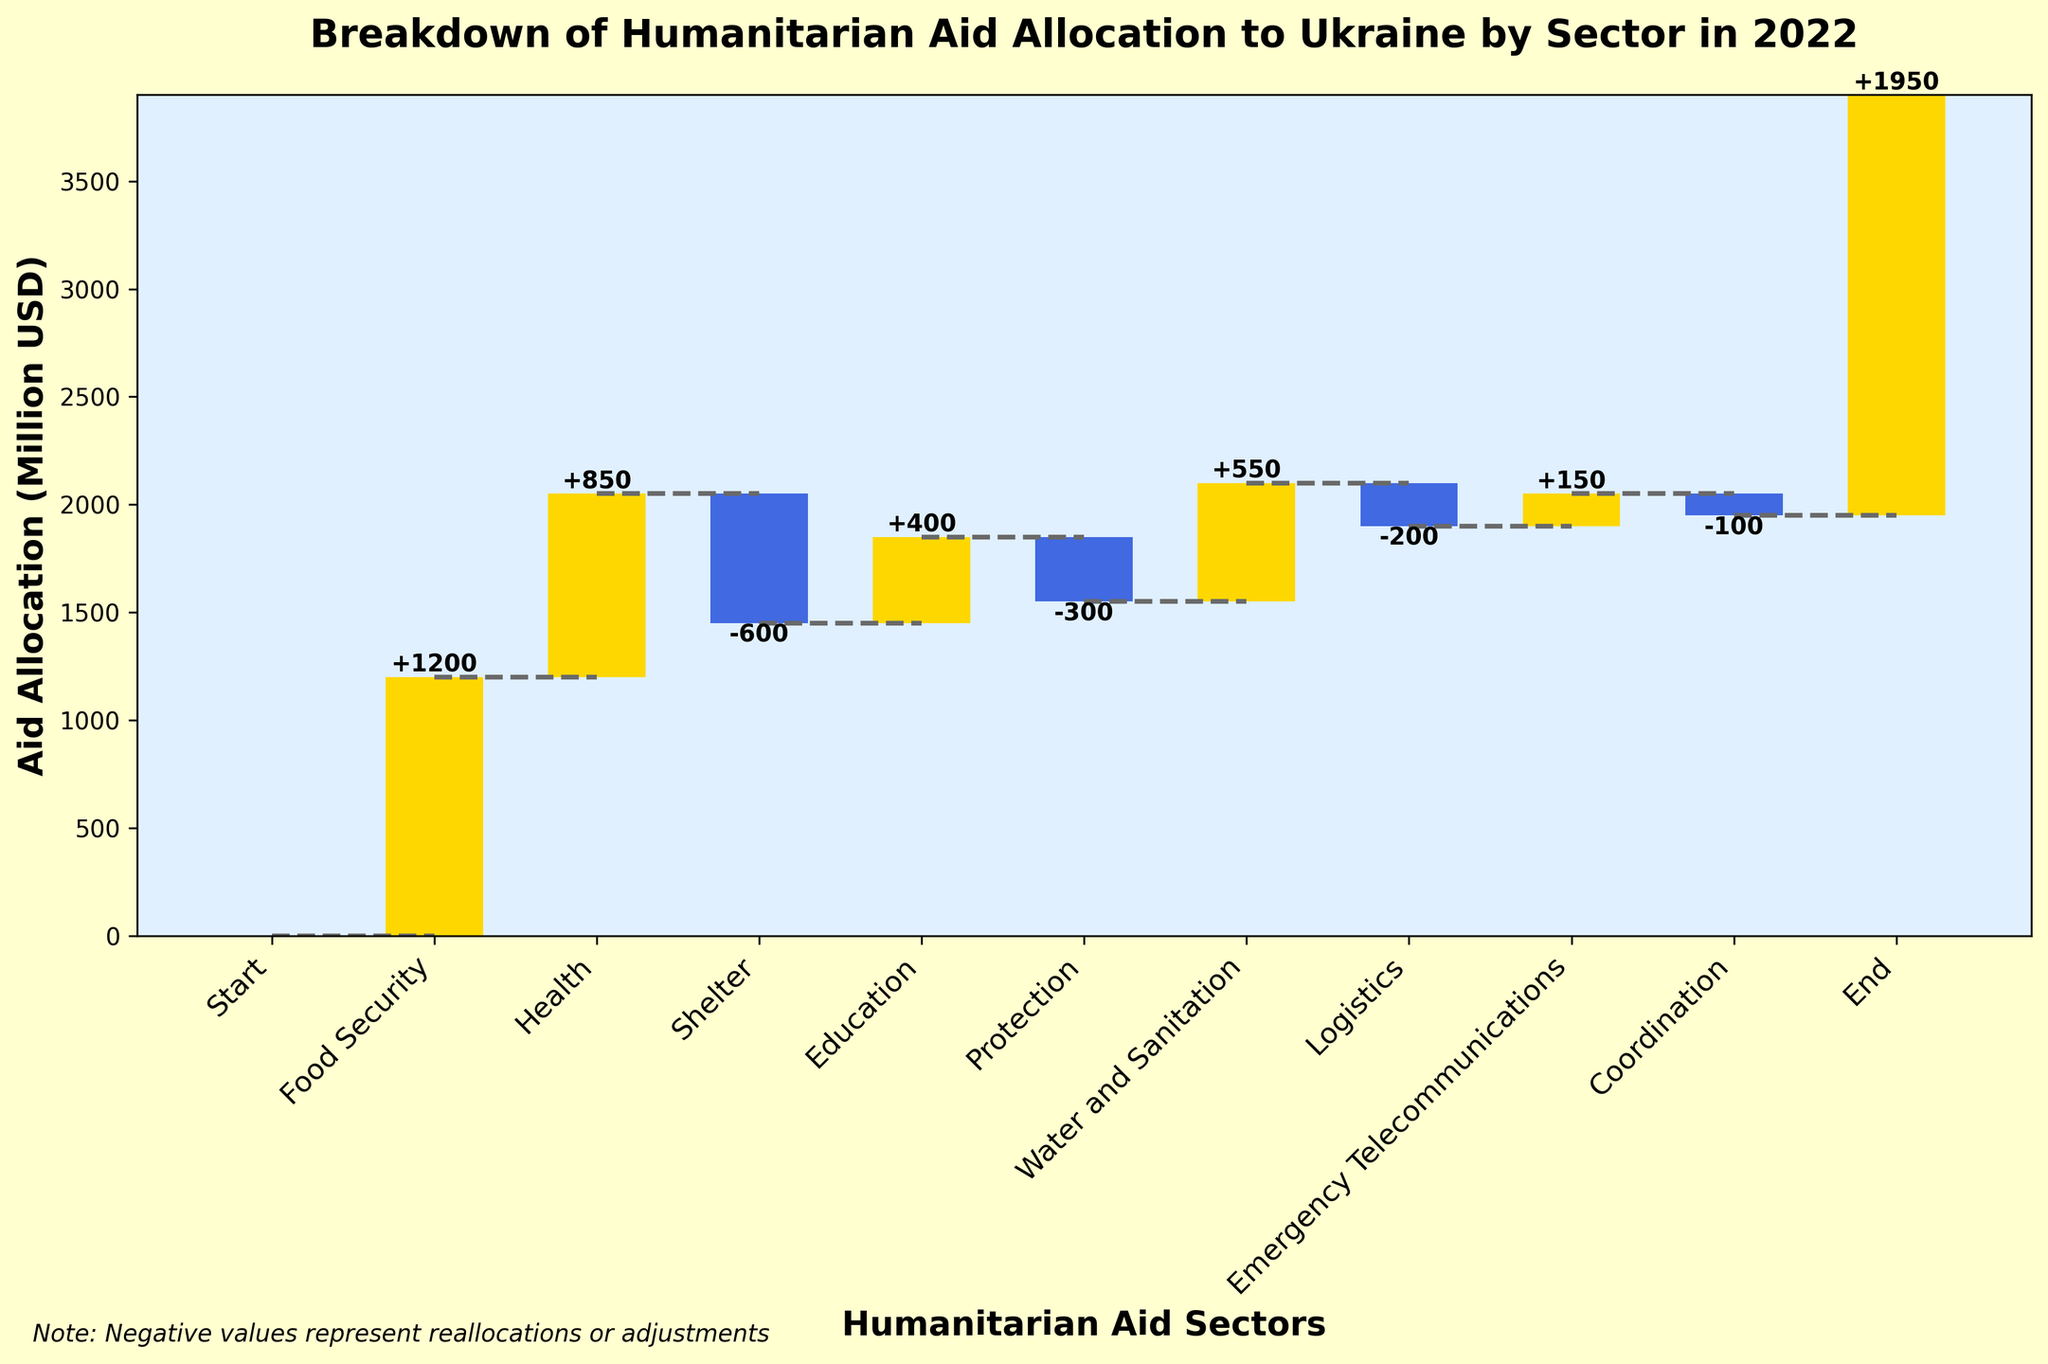How much funding was allocated to the "Food Security" sector? The "Food Security" bar is labeled with the value, which shows an increase of 1200 million USD.
Answer: 1200 million USD What is the final cumulative amount of aid allocation? The chart's final value under "End" shows the cumulative sum of all the allocations and adjustments, which is 1950 million USD.
Answer: 1950 million USD Which sector had the largest negative adjustment? By examining the bars representing negative values (in blue), the "Shelter" sector shows the largest negative adjustment of -600 million USD.
Answer: Shelter What is the total amount of positive allocations (excluding adjustments)? Sum the positive values: Food Security (1200) + Health (850) + Education (400) + Water and Sanitation (550) + Emergency Telecommunications (150) = 3150 million USD.
Answer: 3150 million USD What is the amount of aid allocated to "Water and Sanitation"? The "Water and Sanitation" bar is labeled with the value, which shows an increase of 550 million USD.
Answer: 550 million USD Which sectors contributed to negative adjustments? The sectors with negative values (in blue) are "Shelter" (-600 million USD), "Protection" (-300 million USD), "Logistics" (-200 million USD), and "Coordination" (-100 million USD).
Answer: Shelter, Protection, Logistics, Coordination What is the net allocation for "Health" and "Protection" combined? Add the values of "Health" (850) and "Protection" (-300): 850 + (-300) = 550 million USD.
Answer: 550 million USD Which sector had a smaller allocation, "Education" or "Emergency Telecommunications"? "Education" had 400 million USD while "Emergency Telecommunications" had 150 million USD, therefore "Emergency Telecommunications" had a smaller allocation.
Answer: Emergency Telecommunications What colors are used for depicting positive and negative values on the chart? Positive values are shown in gold (yellow), and negative values are shown in royal blue.
Answer: Gold (yellow) for positive, Royal blue for negative What is the cumulative sum before the "End" category? Examine the cumulative sum just before the final "End" point: the last bar's bottom value is 1950 million USD, which indicates the cumulative sum before the "End".
Answer: 1950 million USD 